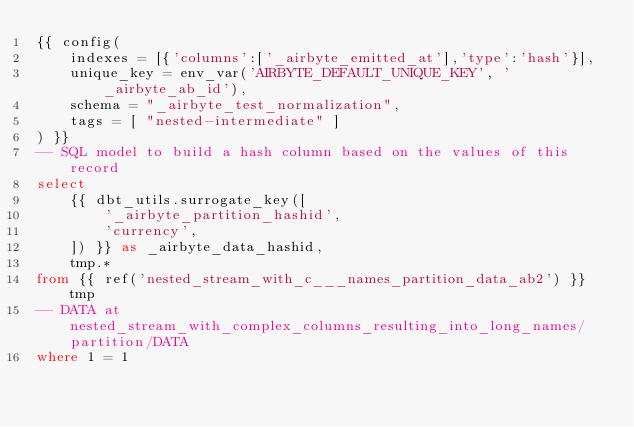Convert code to text. <code><loc_0><loc_0><loc_500><loc_500><_SQL_>{{ config(
    indexes = [{'columns':['_airbyte_emitted_at'],'type':'hash'}],
    unique_key = env_var('AIRBYTE_DEFAULT_UNIQUE_KEY', '_airbyte_ab_id'),
    schema = "_airbyte_test_normalization",
    tags = [ "nested-intermediate" ]
) }}
-- SQL model to build a hash column based on the values of this record
select
    {{ dbt_utils.surrogate_key([
        '_airbyte_partition_hashid',
        'currency',
    ]) }} as _airbyte_data_hashid,
    tmp.*
from {{ ref('nested_stream_with_c___names_partition_data_ab2') }} tmp
-- DATA at nested_stream_with_complex_columns_resulting_into_long_names/partition/DATA
where 1 = 1

</code> 